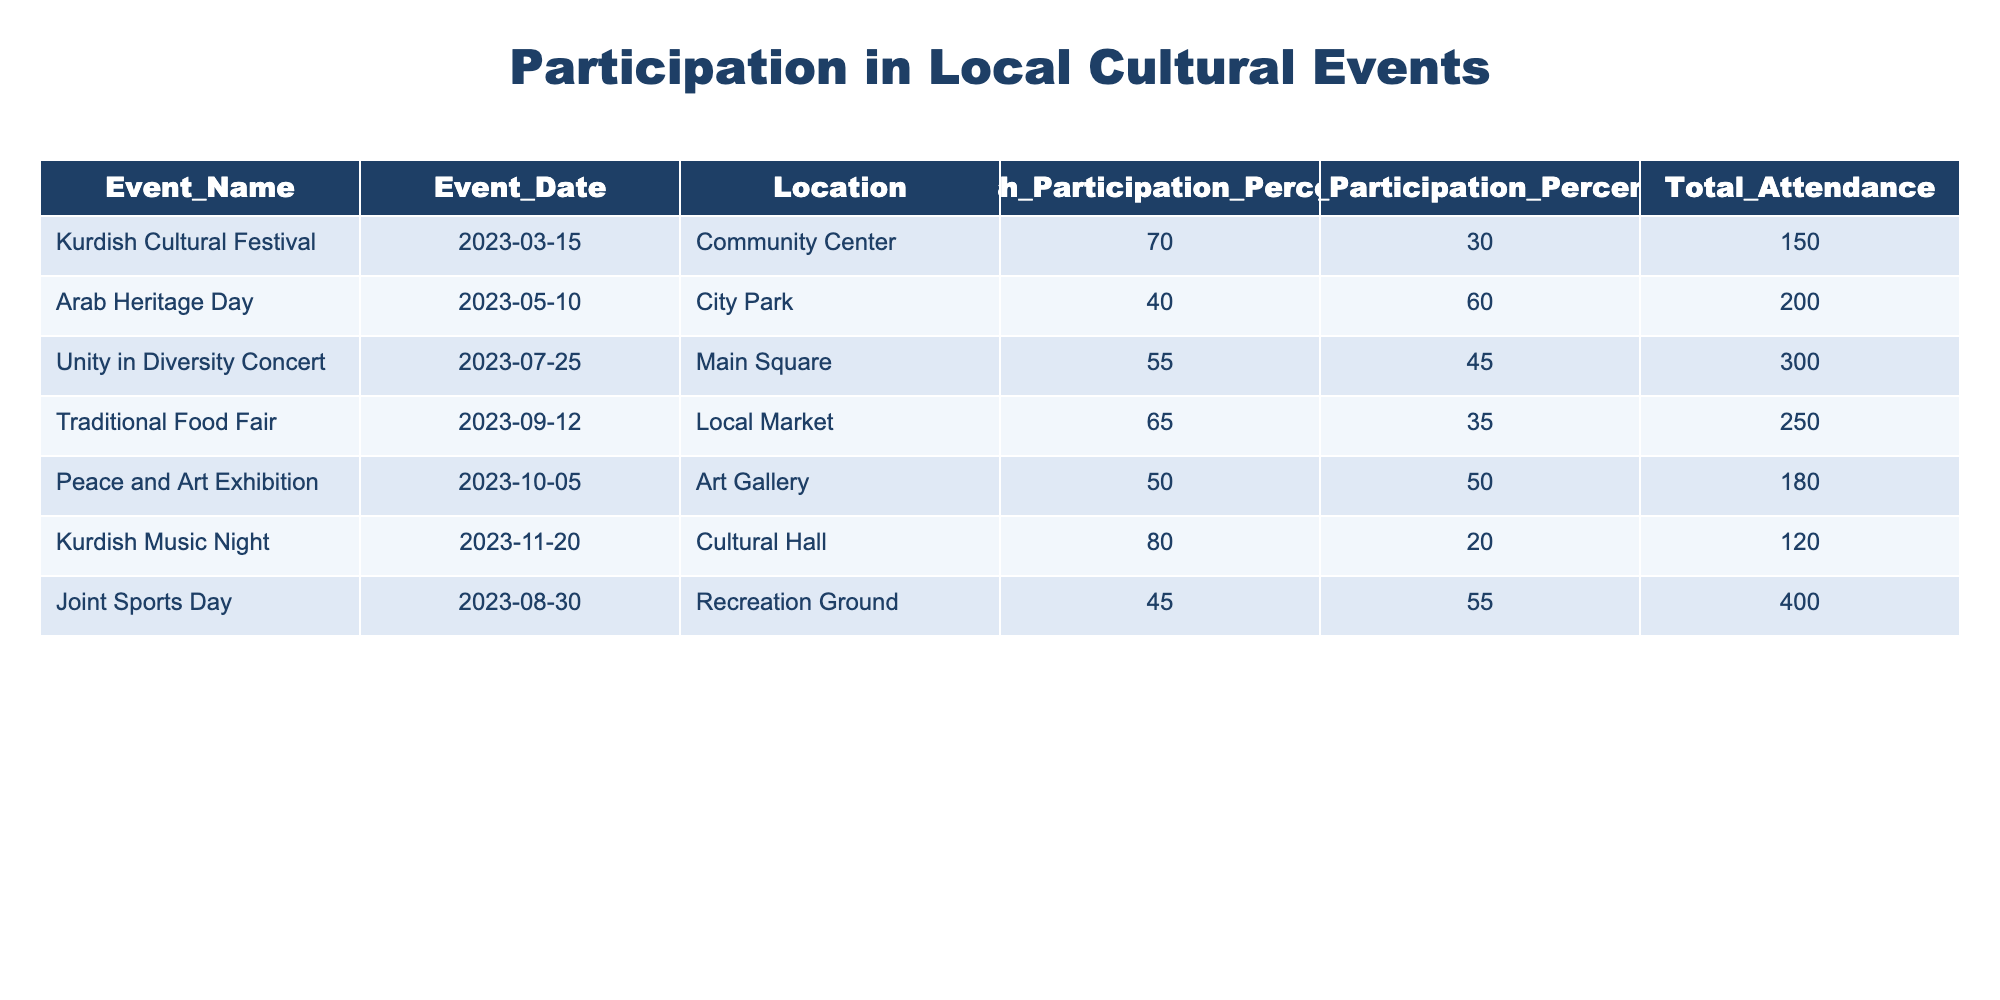What is the total attendance at the Joint Sports Day? The Joint Sports Day is listed in the table with a Total Attendance value of 400. Therefore, the total attendance for this event is directly retrieved from the table.
Answer: 400 What was the Kurdish participation percentage at the Peace and Art Exhibition? From the table, the Peace and Art Exhibition has a Kurdish Participation Percentage of 50%. This value is explicitly stated in the table.
Answer: 50 Which event had the highest Kurdish participation percentage? Reviewing the table, the Kurdish Music Night has the highest participation percentage at 80%. This involves inspecting the Kurdish participation values and identifying the maximum.
Answer: 80 Was there ever an event where the participation percentage of Arabs was greater than 50%? By examining the table, the Arab Heritage Day has an Arab participation percentage of 60%, which is greater than 50%. This confirms that such an event did occur.
Answer: Yes What is the average participation percentage of Arabs across all events listed? The Arab participation percentages are 30, 60, 45, 35, 50, 20, and 55. Adding these values gives 295, and dividing by the number of events (7) results in an average of approximately 42.14. Therefore, the average percentage is calculated as 295/7.
Answer: 42.14 What event had the lowest total attendance? By reviewing the Total Attendance column in the table, the Kurdish Music Night with an attendance of 120 has the lowest total number. This requires comparing all attendance values to find the minimum.
Answer: 120 How many events had a Kurdish participation percentage above 60%? The events with Kurdish participation above 60% are the Kurdish Cultural Festival (70%) and the Kurdish Music Night (80%). Therefore, counting these events shows there are 2 such instances.
Answer: 2 What is the difference between the highest and lowest participation percentages of the Kurdish community? The highest Kurdish participation is 80% (Kurdish Music Night) and the lowest is 40% (Arab Heritage Day). To find the difference, subtract the lowest from the highest: 80 - 40 = 40.
Answer: 40 